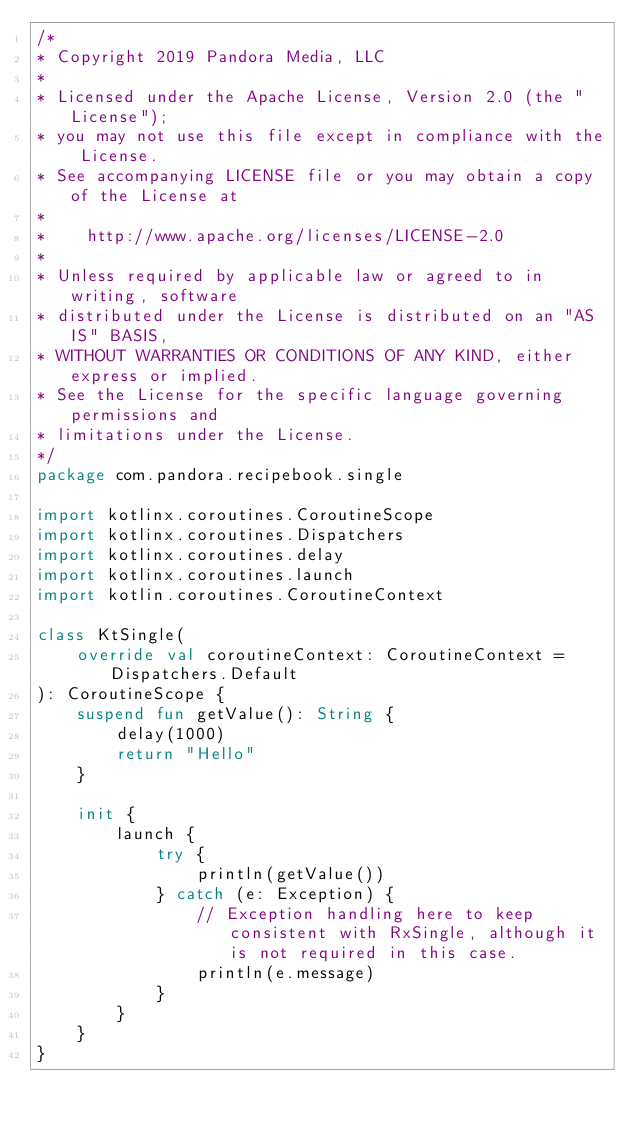<code> <loc_0><loc_0><loc_500><loc_500><_Kotlin_>/*
* Copyright 2019 Pandora Media, LLC
*
* Licensed under the Apache License, Version 2.0 (the "License");
* you may not use this file except in compliance with the License.
* See accompanying LICENSE file or you may obtain a copy of the License at
*
*    http://www.apache.org/licenses/LICENSE-2.0
*
* Unless required by applicable law or agreed to in writing, software
* distributed under the License is distributed on an "AS IS" BASIS,
* WITHOUT WARRANTIES OR CONDITIONS OF ANY KIND, either express or implied.
* See the License for the specific language governing permissions and
* limitations under the License.
*/
package com.pandora.recipebook.single

import kotlinx.coroutines.CoroutineScope
import kotlinx.coroutines.Dispatchers
import kotlinx.coroutines.delay
import kotlinx.coroutines.launch
import kotlin.coroutines.CoroutineContext

class KtSingle(
    override val coroutineContext: CoroutineContext = Dispatchers.Default
): CoroutineScope {
    suspend fun getValue(): String {
        delay(1000)
        return "Hello"
    }

    init {
        launch {
            try {
                println(getValue())
            } catch (e: Exception) {
                // Exception handling here to keep consistent with RxSingle, although it is not required in this case.
                println(e.message)
            }
        }
    }
}</code> 